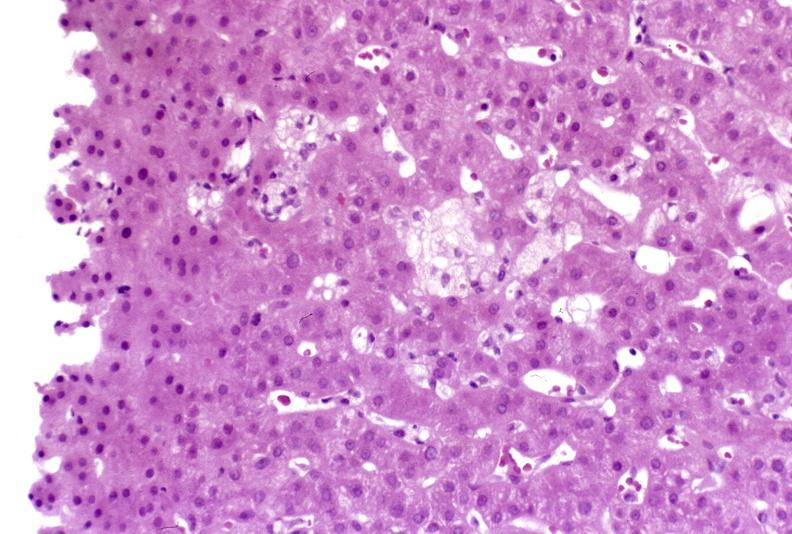does this image show recovery of ducts?
Answer the question using a single word or phrase. Yes 